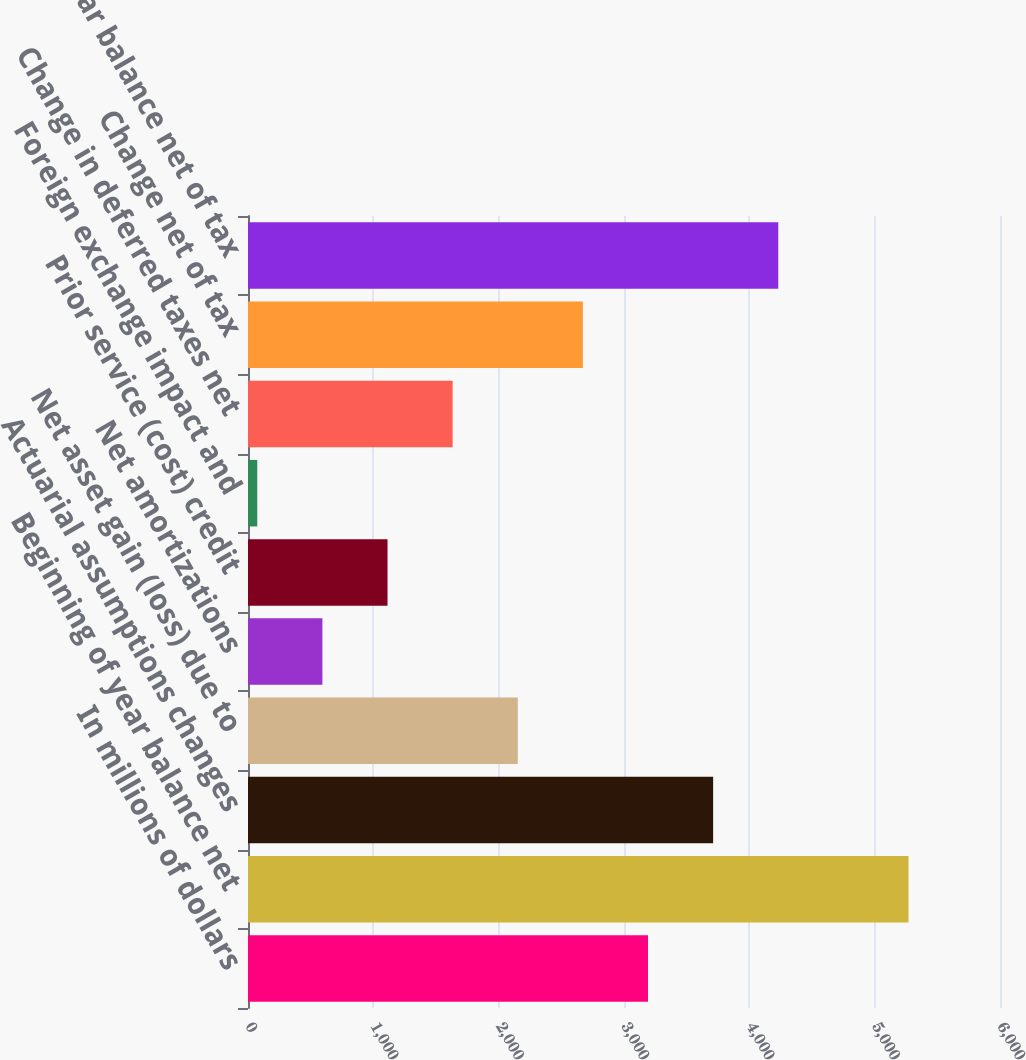Convert chart to OTSL. <chart><loc_0><loc_0><loc_500><loc_500><bar_chart><fcel>In millions of dollars<fcel>Beginning of year balance net<fcel>Actuarial assumptions changes<fcel>Net asset gain (loss) due to<fcel>Net amortizations<fcel>Prior service (cost) credit<fcel>Foreign exchange impact and<fcel>Change in deferred taxes net<fcel>Change net of tax<fcel>End of year balance net of tax<nl><fcel>3191.6<fcel>5270<fcel>3711.2<fcel>2152.4<fcel>593.6<fcel>1113.2<fcel>74<fcel>1632.8<fcel>2672<fcel>4230.8<nl></chart> 